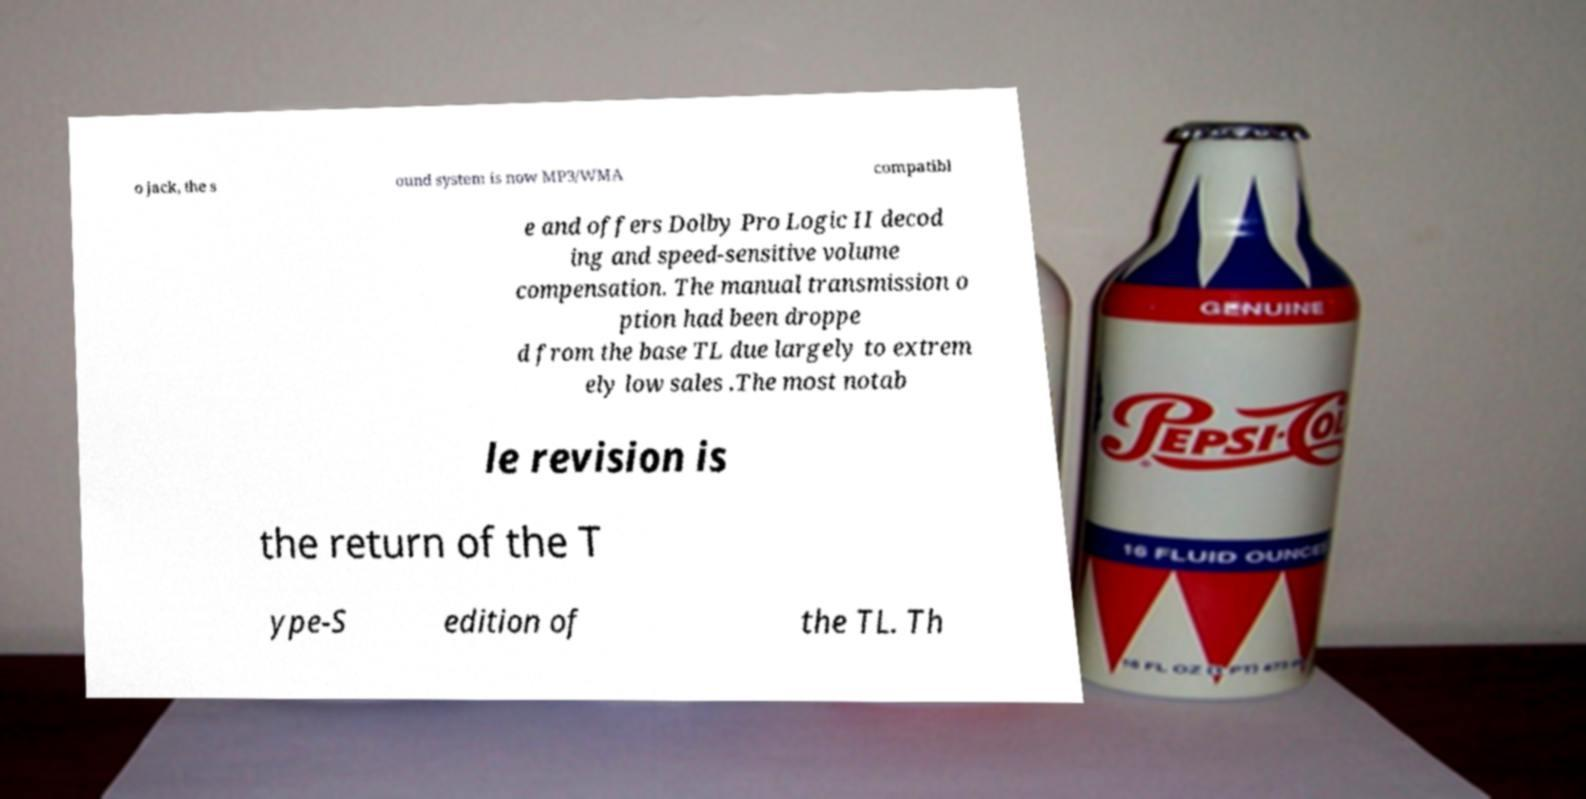Can you accurately transcribe the text from the provided image for me? o jack, the s ound system is now MP3/WMA compatibl e and offers Dolby Pro Logic II decod ing and speed-sensitive volume compensation. The manual transmission o ption had been droppe d from the base TL due largely to extrem ely low sales .The most notab le revision is the return of the T ype-S edition of the TL. Th 